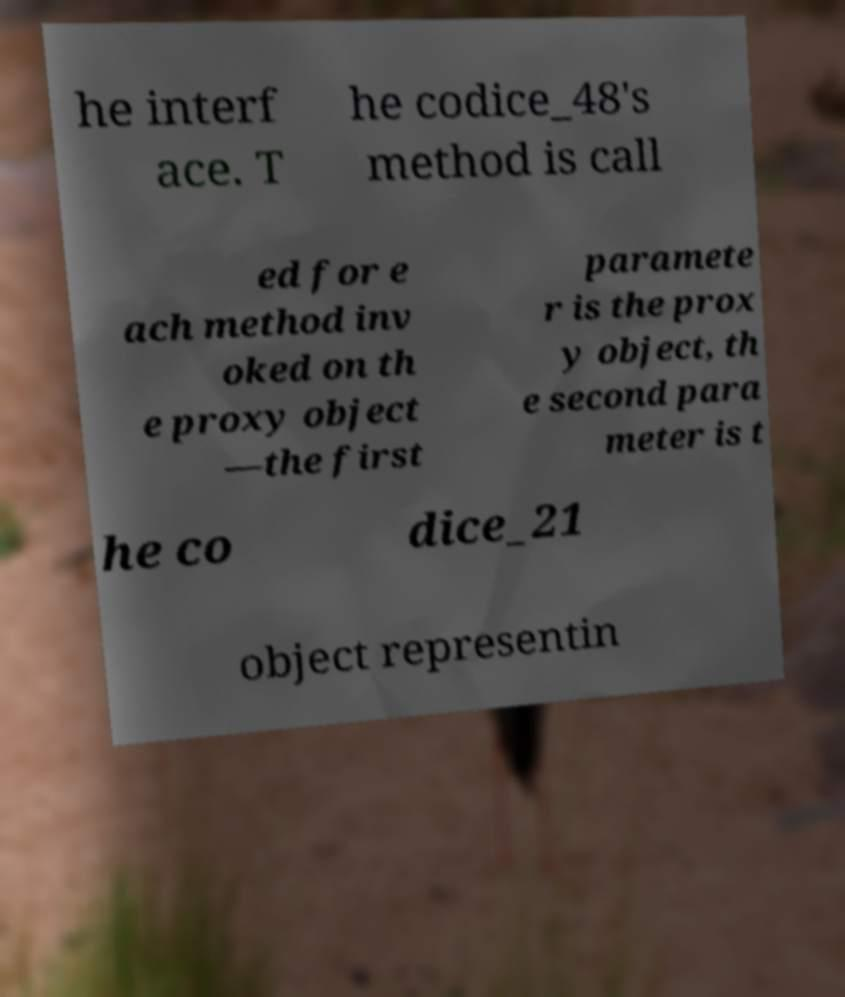There's text embedded in this image that I need extracted. Can you transcribe it verbatim? he interf ace. T he codice_48's method is call ed for e ach method inv oked on th e proxy object —the first paramete r is the prox y object, th e second para meter is t he co dice_21 object representin 